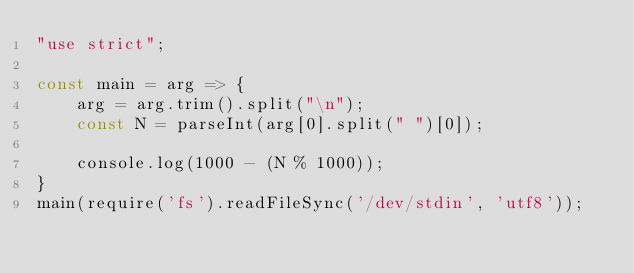<code> <loc_0><loc_0><loc_500><loc_500><_JavaScript_>"use strict";
    
const main = arg => {
    arg = arg.trim().split("\n");
    const N = parseInt(arg[0].split(" ")[0]);
    
    console.log(1000 - (N % 1000));
}
main(require('fs').readFileSync('/dev/stdin', 'utf8'));</code> 